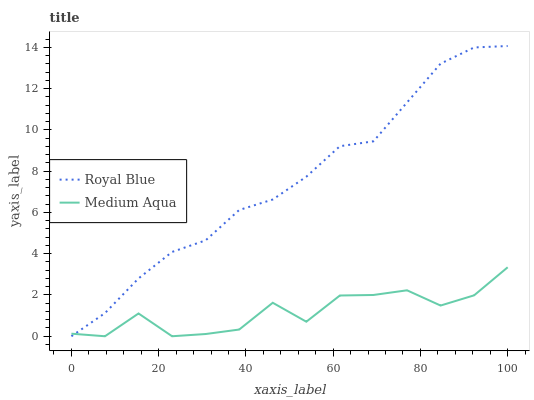Does Medium Aqua have the minimum area under the curve?
Answer yes or no. Yes. Does Royal Blue have the maximum area under the curve?
Answer yes or no. Yes. Does Medium Aqua have the maximum area under the curve?
Answer yes or no. No. Is Royal Blue the smoothest?
Answer yes or no. Yes. Is Medium Aqua the roughest?
Answer yes or no. Yes. Is Medium Aqua the smoothest?
Answer yes or no. No. Does Royal Blue have the lowest value?
Answer yes or no. Yes. Does Royal Blue have the highest value?
Answer yes or no. Yes. Does Medium Aqua have the highest value?
Answer yes or no. No. Does Medium Aqua intersect Royal Blue?
Answer yes or no. Yes. Is Medium Aqua less than Royal Blue?
Answer yes or no. No. Is Medium Aqua greater than Royal Blue?
Answer yes or no. No. 